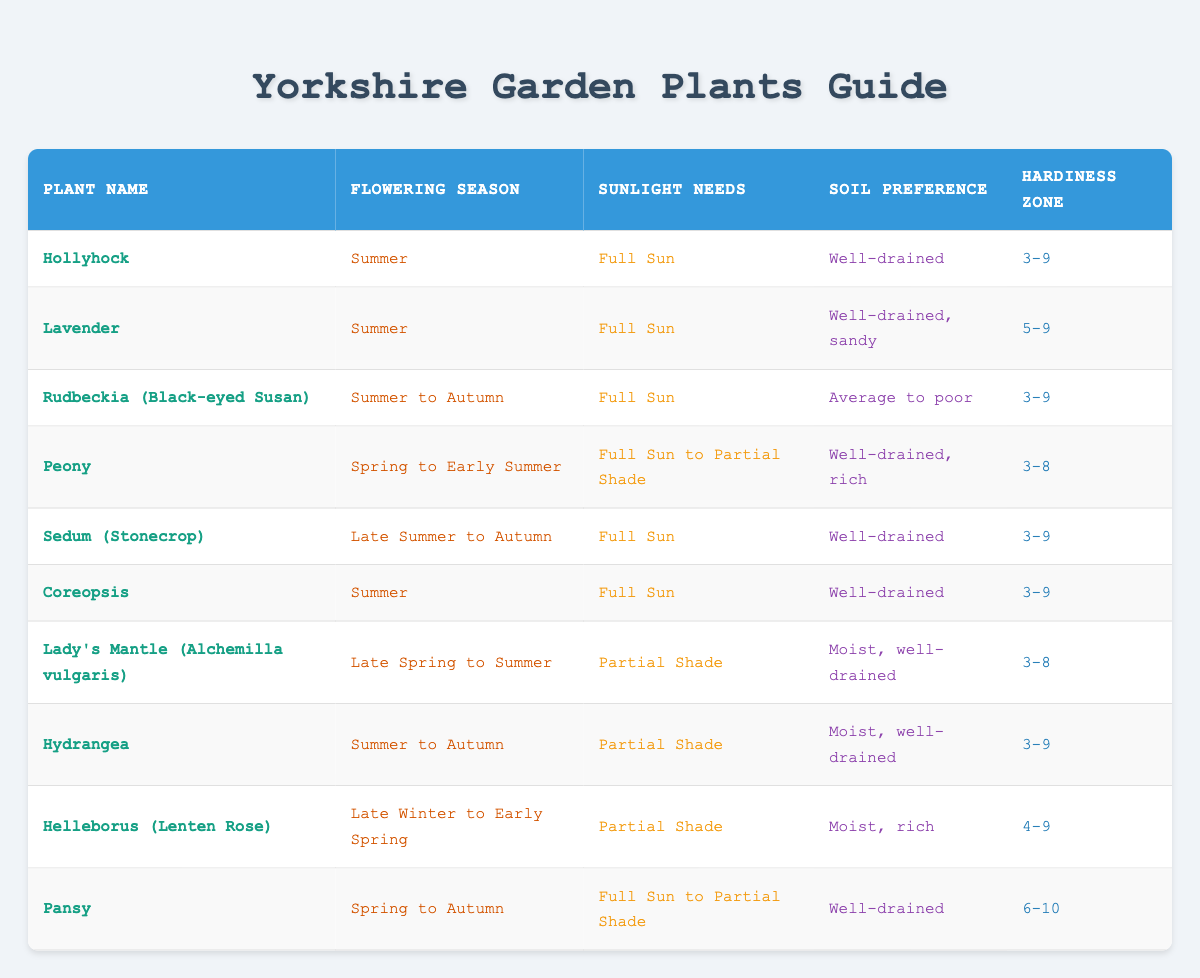What is the flowering season for Lavender? The table indicates the flowering season for Lavender in the corresponding row, which is listed as Summer.
Answer: Summer Which plant requires partial shade? Looking through the sunlight needs column, I see that both Lady's Mantle and Hydrangea are indicated as requiring Partial Shade.
Answer: Lady's Mantle, Hydrangea Which plants are suitable for hardiness zone 3? The hardiness zone column shows both Hollyhock, Rudbeckia, Sedum, Coreopsis, and Lady's Mantle as being in zone 3.
Answer: Hollyhock, Rudbeckia, Sedum, Coreopsis, Lady's Mantle Is Pansy suitable for a full sun location? The sunlight needs column for Pansy states "Full Sun to Partial Shade." Therefore, it can indeed thrive in a full sun location.
Answer: Yes How many plants prefer well-drained soil? By scanning the soil preference column, I can identify that Hollyhock, Lavender, Sedum, Coreopsis, and Pansy require well-drained soil; that makes a total of 5 plants.
Answer: 5 What is the average hardiness zone for the plants listed? The unique hardiness zones from the table are 3-9, 5-9, 3-8, 4-9, and 6-10. To calculate the average: summing the minimums (3 + 5 + 3 + 4 + 6) = 21 and taking the mean value (21/5) = 4.2. We take the average for maximums (9 + 9 + 8 + 9 + 10) = 45, thus (45/5) = 9. Therefore, the average hardiness zone rounds to 4-9.
Answer: 4-9 Which plant flowers from late winter to early spring? Helleborus is the only plant listed with the flowering season of Late Winter to Early Spring.
Answer: Helleborus Are there any plants that thrive in both full sun and partial shade? Peony and Pansy are indicated in the sunlight needs column as being acceptable in both full sun and partial shade situations.
Answer: Peony, Pansy Which plant has the broadest hardiness zone range, and what is that range? Scanning the hardiness zone column, Pansy is indicated with the range of 6-10, while Helleborus has 4-9. Pansy has the broadest range of 6-10.
Answer: Pansy, 6-10 